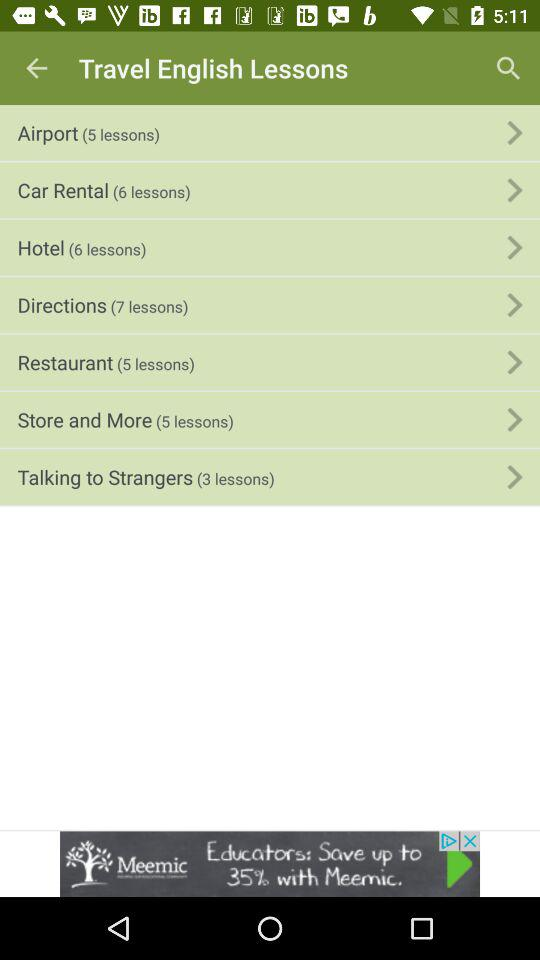How many lessons are in the Restaurant section?
Answer the question using a single word or phrase. 5 